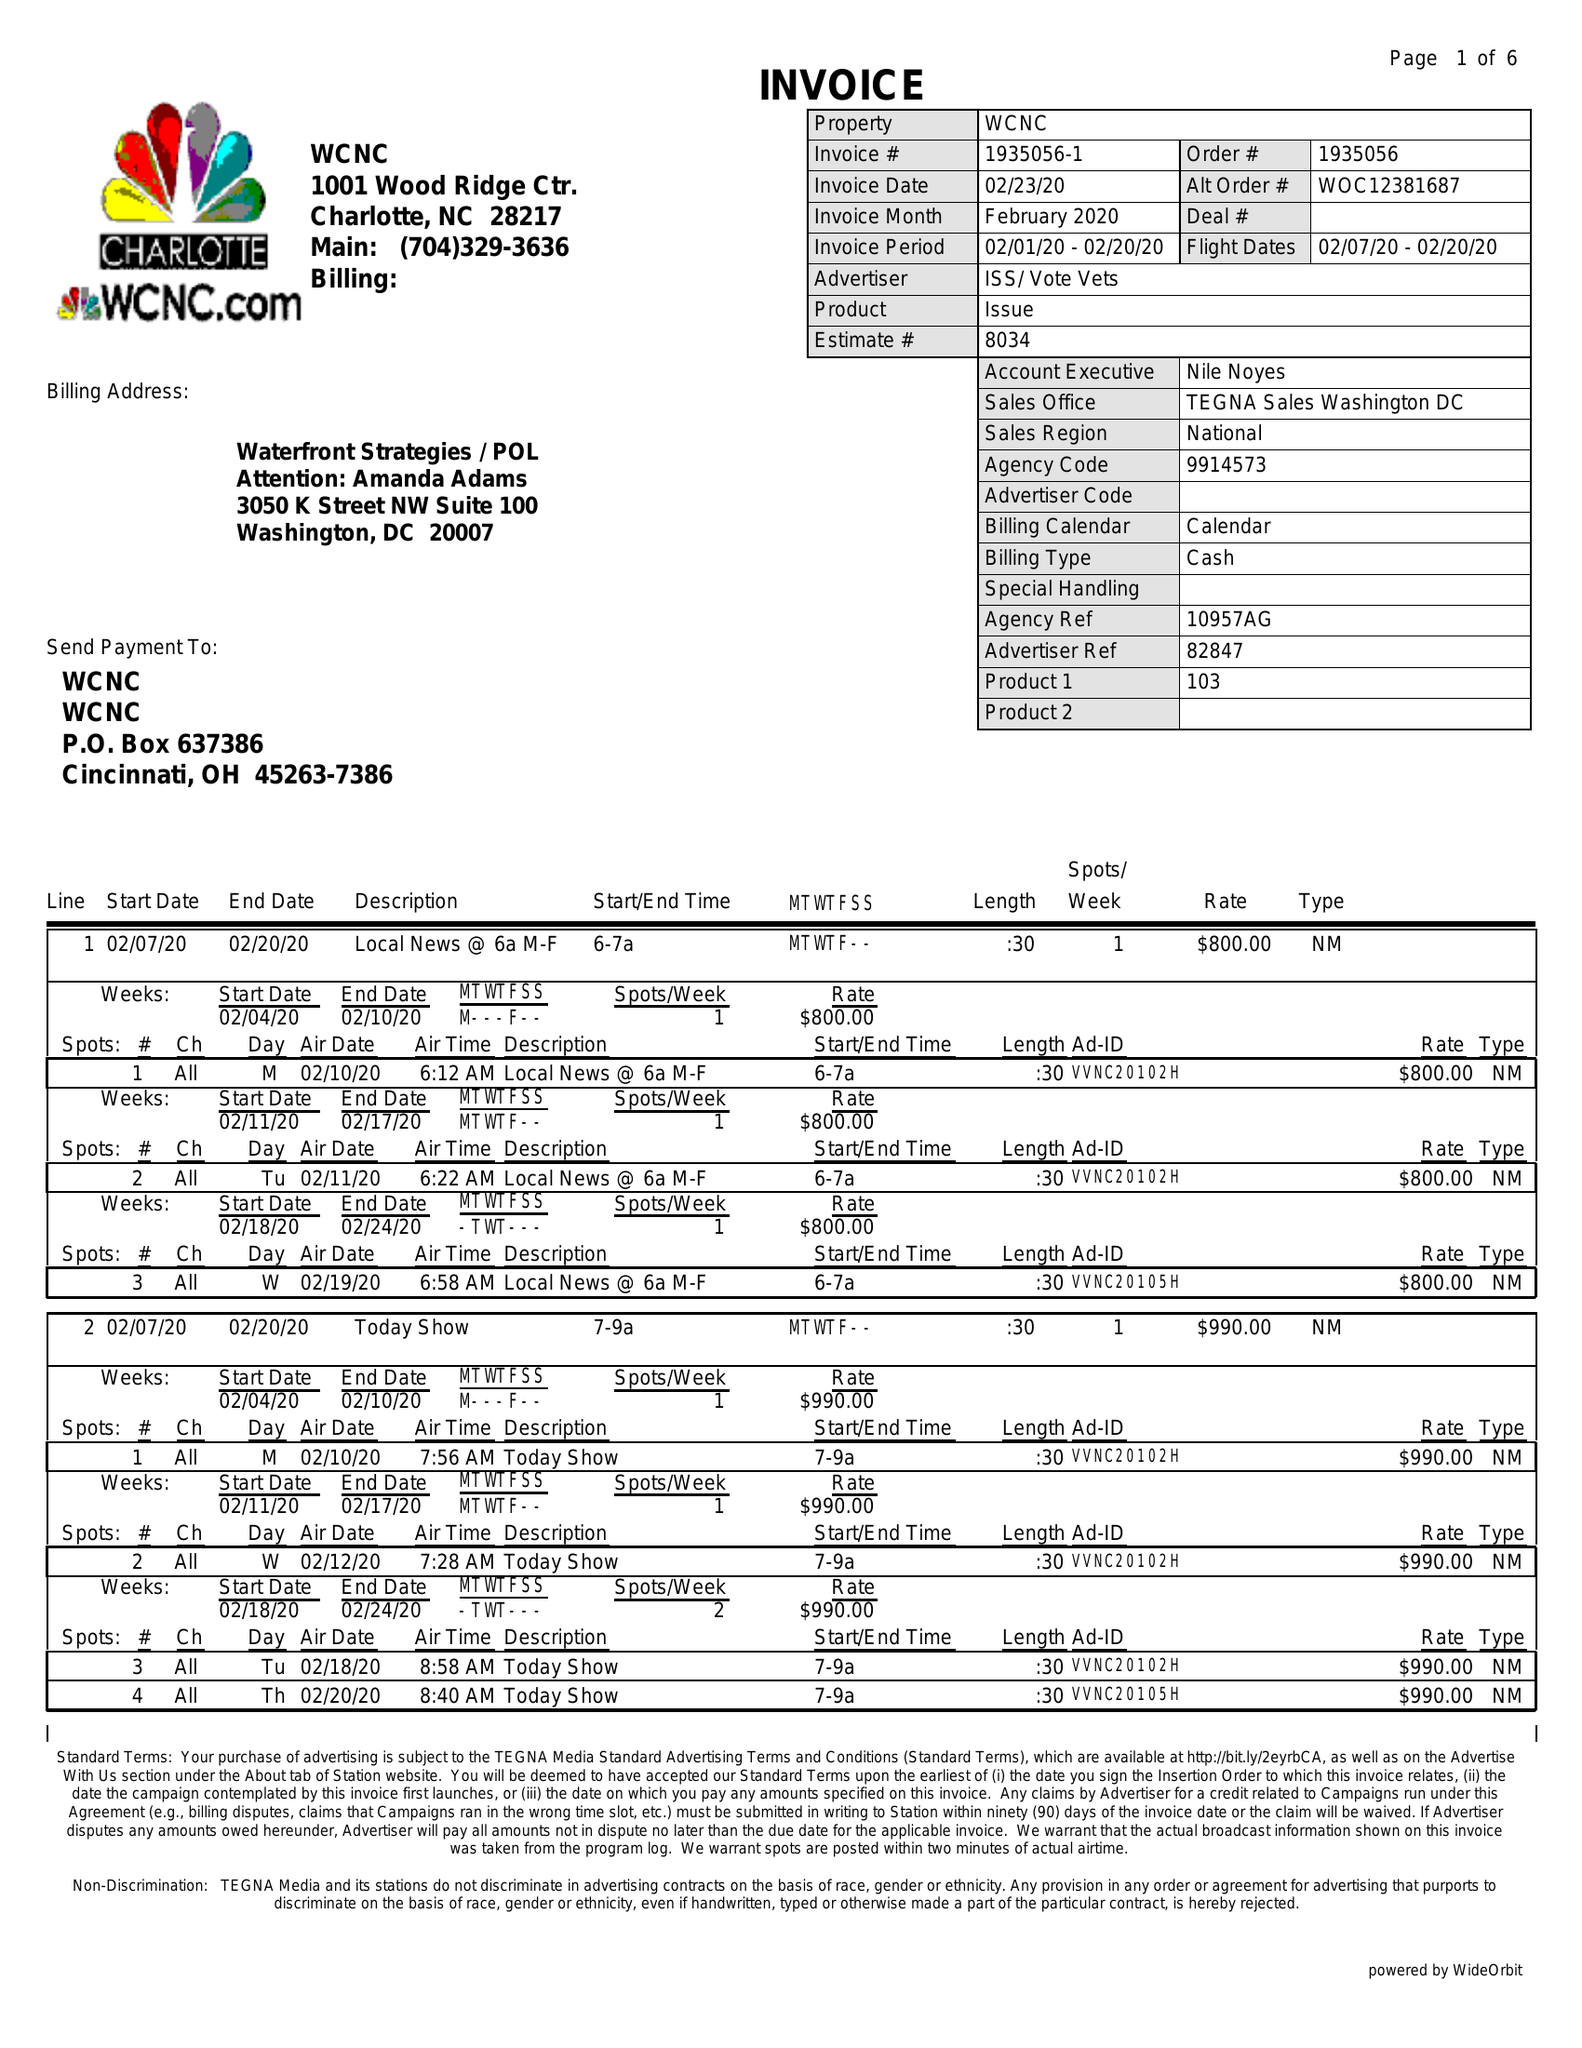What is the value for the advertiser?
Answer the question using a single word or phrase. ISS/VOTEVETS 